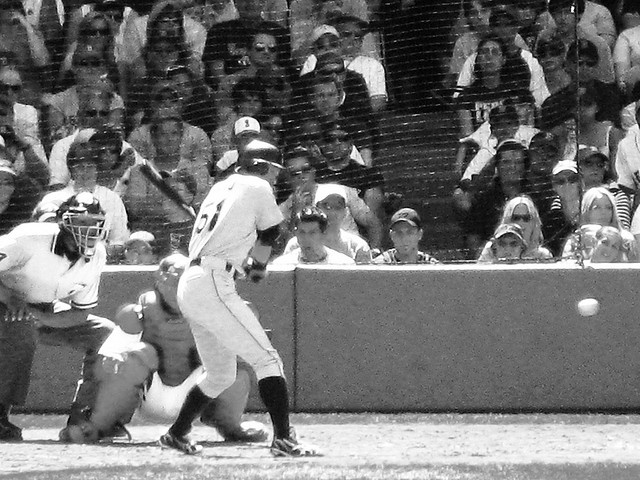Describe the objects in this image and their specific colors. I can see people in black, white, gray, and darkgray tones, people in black, gainsboro, darkgray, and gray tones, people in black, gray, and white tones, people in black, gray, darkgray, and white tones, and people in black, gray, darkgray, and lightgray tones in this image. 